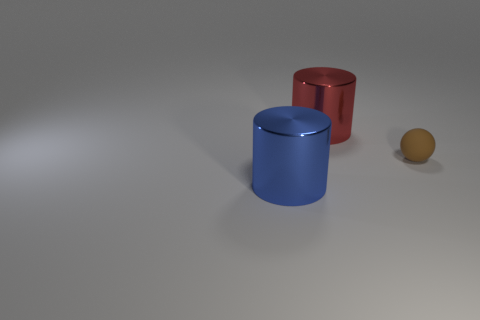Add 3 big red things. How many objects exist? 6 Subtract all spheres. How many objects are left? 2 Subtract 0 blue cubes. How many objects are left? 3 Subtract all tiny balls. Subtract all small rubber things. How many objects are left? 1 Add 3 red cylinders. How many red cylinders are left? 4 Add 2 big cylinders. How many big cylinders exist? 4 